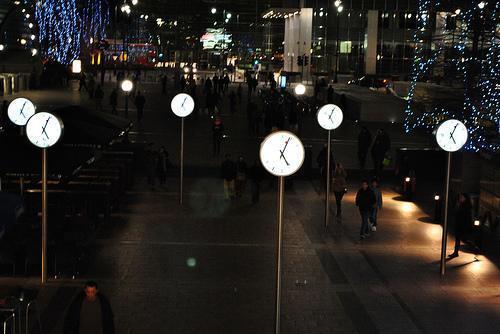How many clock faces are fully visible?
Give a very brief answer. 6. How many clocks are in the photo?
Give a very brief answer. 7. How many street lights are in the photo?
Give a very brief answer. 2. 